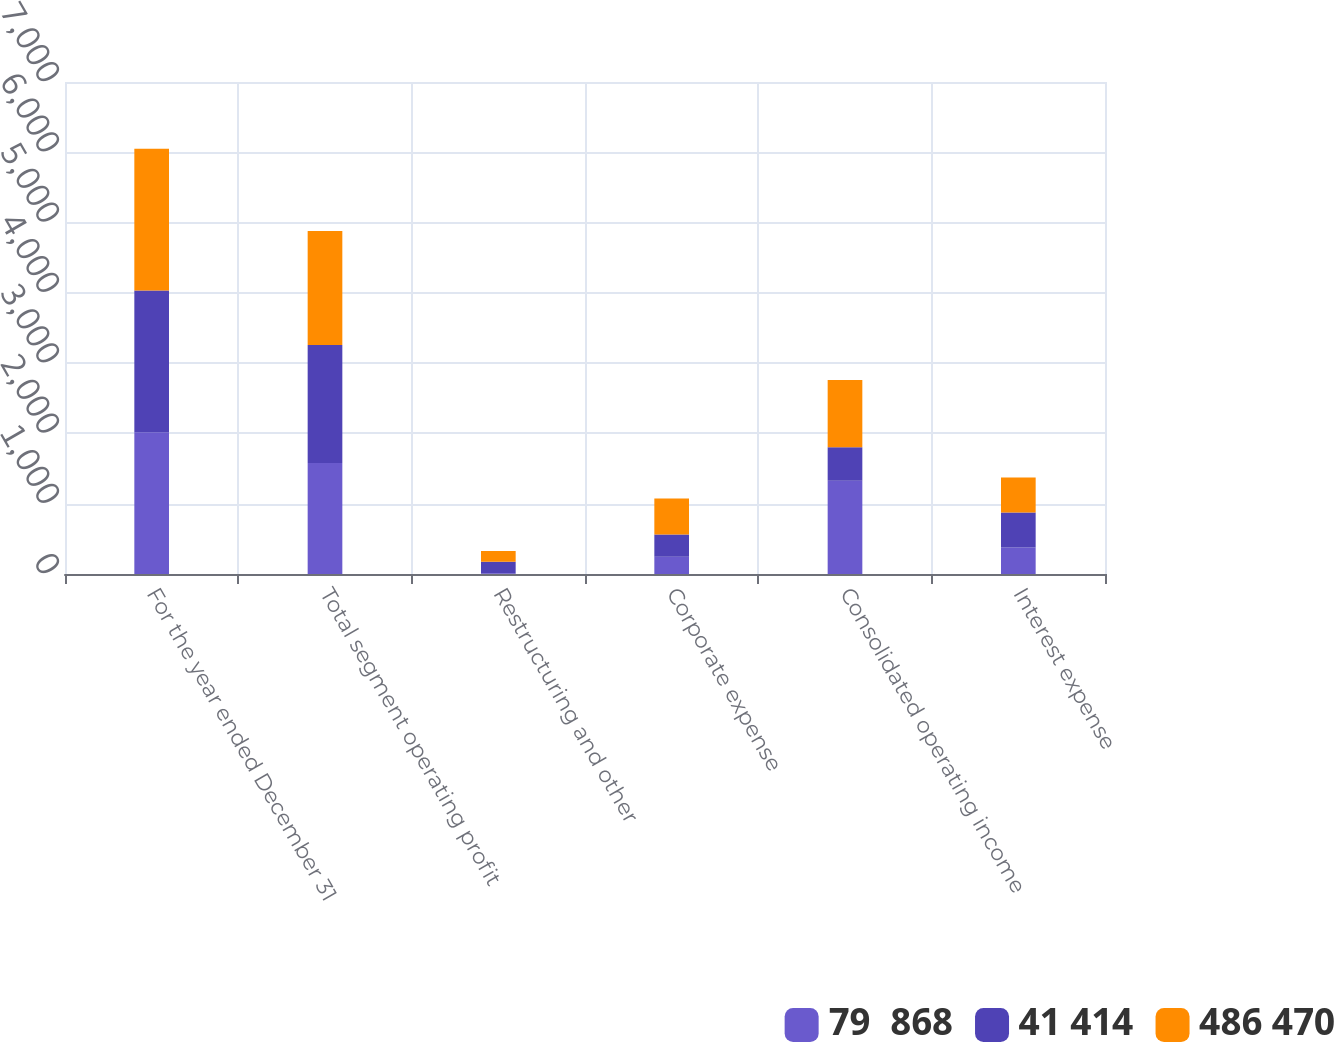Convert chart to OTSL. <chart><loc_0><loc_0><loc_500><loc_500><stacked_bar_chart><ecel><fcel>For the year ended December 31<fcel>Total segment operating profit<fcel>Restructuring and other<fcel>Corporate expense<fcel>Consolidated operating income<fcel>Interest expense<nl><fcel>79  868<fcel>2018<fcel>1581<fcel>9<fcel>247<fcel>1325<fcel>378<nl><fcel>41 414<fcel>2017<fcel>1678<fcel>165<fcel>314<fcel>480<fcel>496<nl><fcel>486 470<fcel>2016<fcel>1622<fcel>155<fcel>513<fcel>954<fcel>499<nl></chart> 